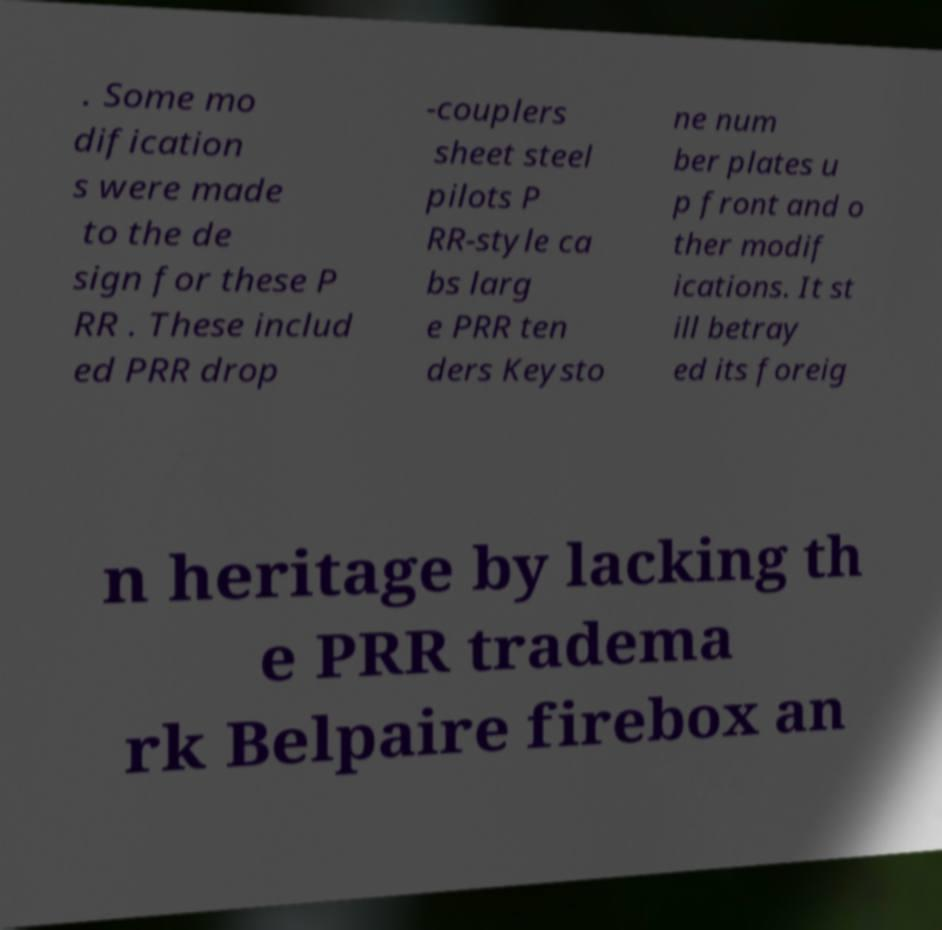For documentation purposes, I need the text within this image transcribed. Could you provide that? . Some mo dification s were made to the de sign for these P RR . These includ ed PRR drop -couplers sheet steel pilots P RR-style ca bs larg e PRR ten ders Keysto ne num ber plates u p front and o ther modif ications. It st ill betray ed its foreig n heritage by lacking th e PRR tradema rk Belpaire firebox an 